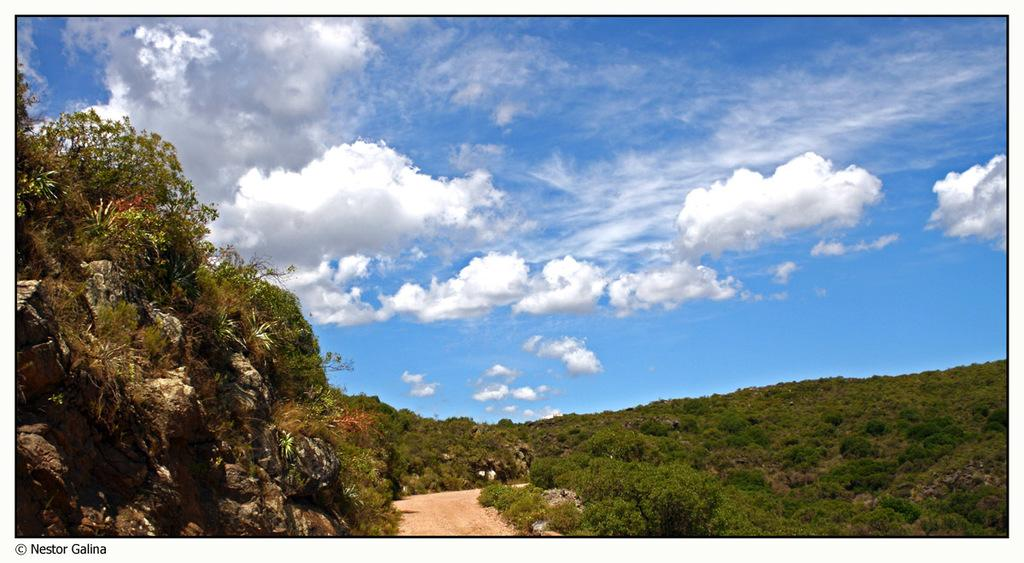What type of natural vegetation is present in the image? There are trees and plants in the image. What other natural elements can be seen in the image? There are rocks in the image. What is visible in the background of the image? The sky is visible in the background of the image. What can be seen in the sky in the image? There are clouds in the sky. Where can the mitten be found in the image? There is no mitten present in the image. What type of lumber is being used to construct the alley in the image? There is no alley or lumber present in the image. 